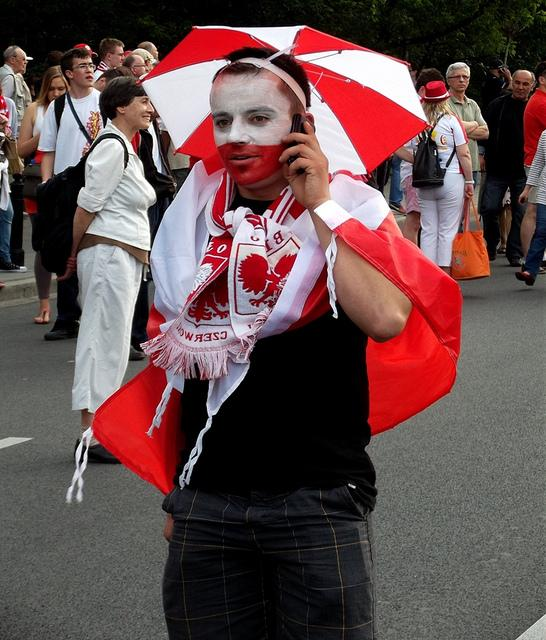Which country has red with white flag?

Choices:
A) dutch
B) poland
C) turkey
D) russia poland 